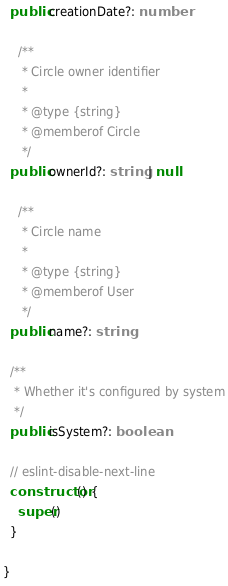<code> <loc_0><loc_0><loc_500><loc_500><_TypeScript_>  public creationDate?: number

    /**
     * Circle owner identifier
     *
     * @type {string}
     * @memberof Circle
     */
  public ownerId?: string | null

    /**
     * Circle name
     *
     * @type {string}
     * @memberof User
     */
  public name?: string

  /**
   * Whether it's configured by system
   */
  public isSystem?: boolean

  // eslint-disable-next-line 
  constructor() {
    super()
  }

}
</code> 